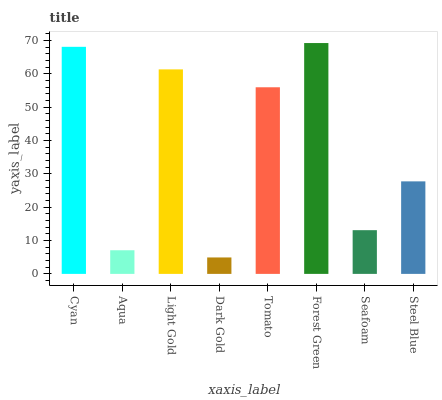Is Dark Gold the minimum?
Answer yes or no. Yes. Is Forest Green the maximum?
Answer yes or no. Yes. Is Aqua the minimum?
Answer yes or no. No. Is Aqua the maximum?
Answer yes or no. No. Is Cyan greater than Aqua?
Answer yes or no. Yes. Is Aqua less than Cyan?
Answer yes or no. Yes. Is Aqua greater than Cyan?
Answer yes or no. No. Is Cyan less than Aqua?
Answer yes or no. No. Is Tomato the high median?
Answer yes or no. Yes. Is Steel Blue the low median?
Answer yes or no. Yes. Is Forest Green the high median?
Answer yes or no. No. Is Light Gold the low median?
Answer yes or no. No. 